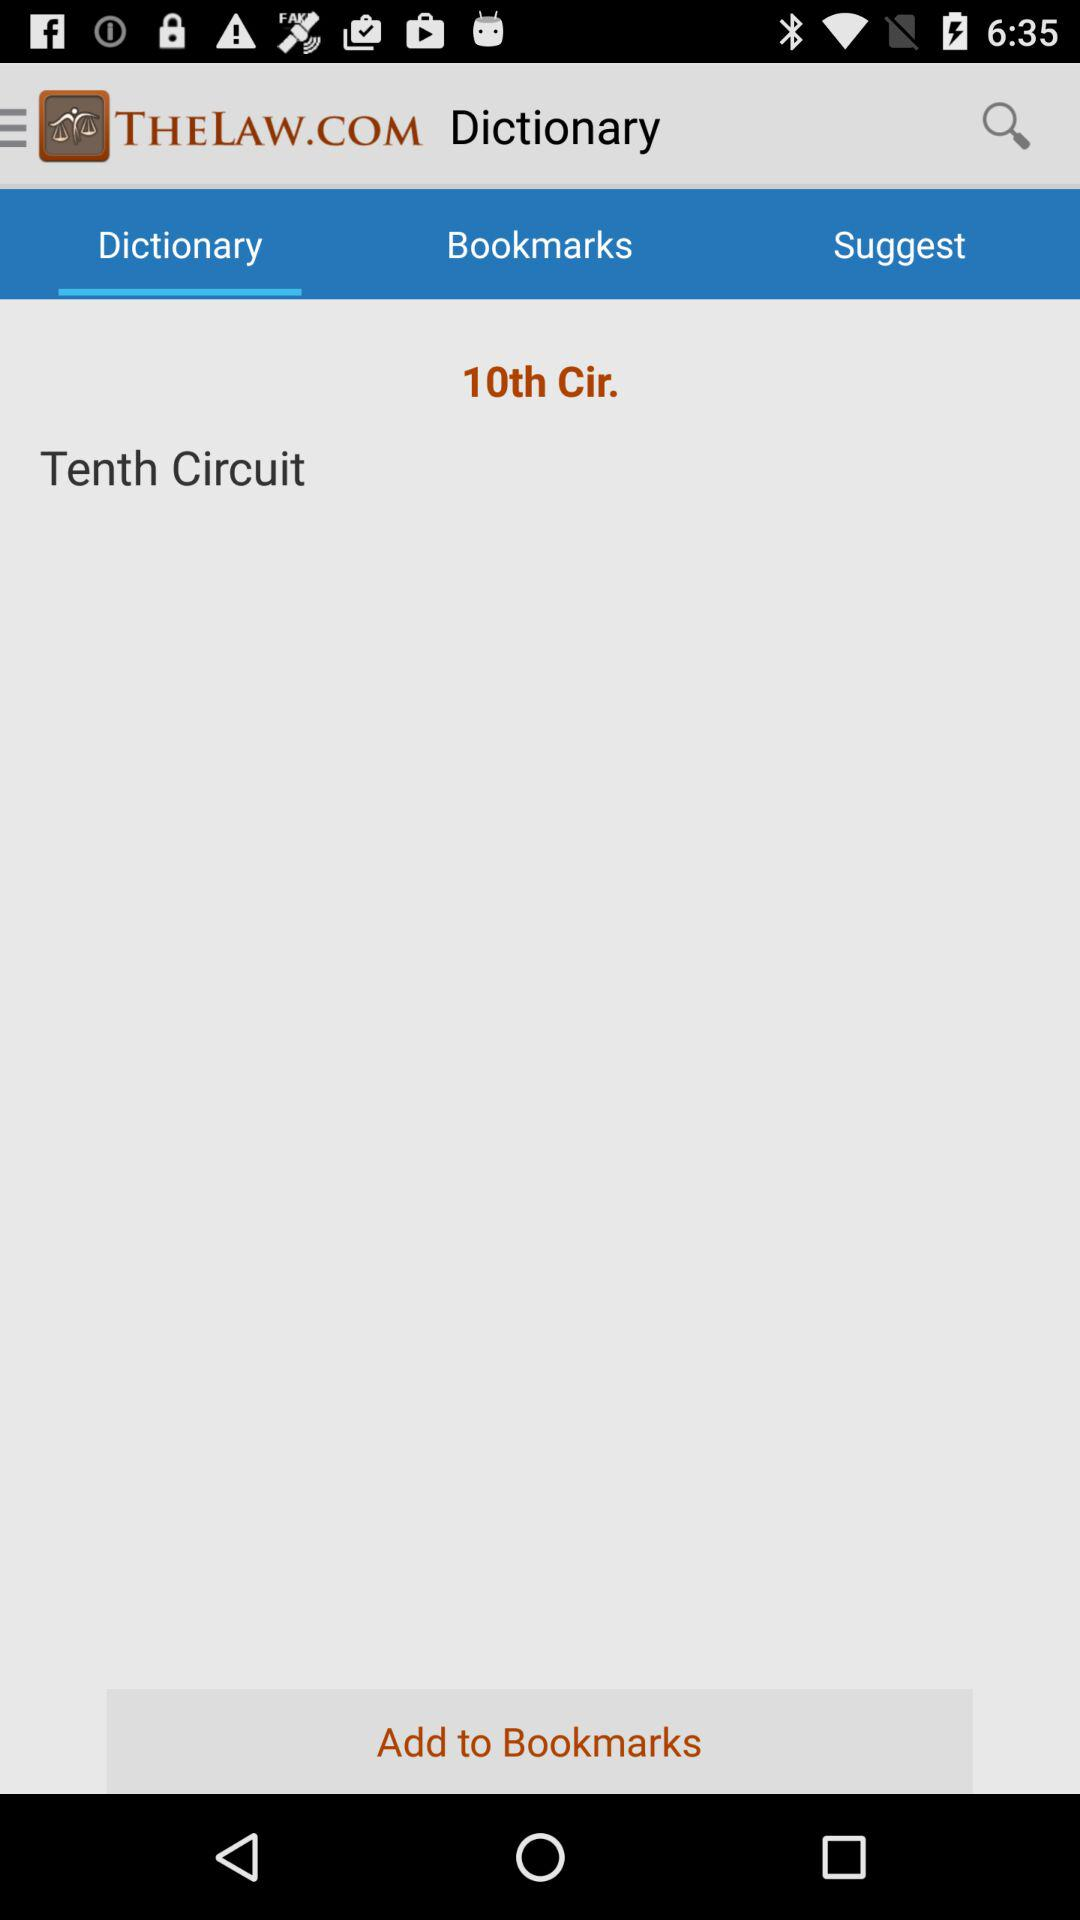What is the name of the application? The name of the application is "THELAW.COM". 